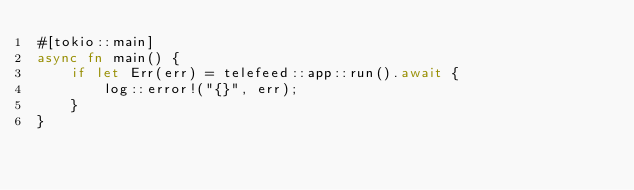Convert code to text. <code><loc_0><loc_0><loc_500><loc_500><_Rust_>#[tokio::main]
async fn main() {
    if let Err(err) = telefeed::app::run().await {
        log::error!("{}", err);
    }
}
</code> 